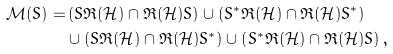Convert formula to latex. <formula><loc_0><loc_0><loc_500><loc_500>\mathcal { M } ( S ) = & \left ( S \mathfrak { R } ( \mathcal { H } ) \cap \mathfrak { R } ( \mathcal { H } ) S \right ) \cup \left ( S ^ { * } \mathfrak { R } ( \mathcal { H } ) \cap \mathfrak { R } ( \mathcal { H } ) S ^ { * } \right ) \\ & \cup \left ( S \mathfrak { R } ( \mathcal { H } ) \cap \mathfrak { R } ( \mathcal { H } ) S ^ { * } \right ) \cup \left ( S ^ { * } \mathfrak { R } ( \mathcal { H } ) \cap \mathfrak { R } ( \mathcal { H } ) S \right ) ,</formula> 